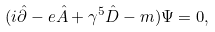<formula> <loc_0><loc_0><loc_500><loc_500>( i \hat { \partial } - e \hat { A } + \gamma ^ { 5 } \hat { D } - m ) \Psi = 0 ,</formula> 